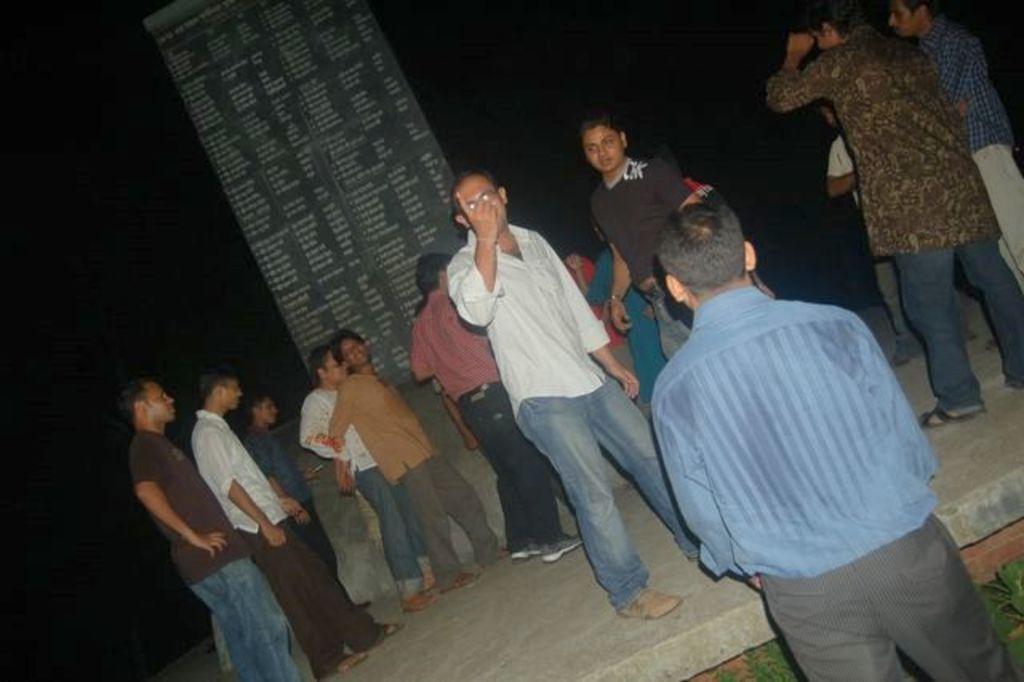How would you summarize this image in a sentence or two? In this image there are group of people standing on floor and there is a board visible in the middle , background is too dark. 